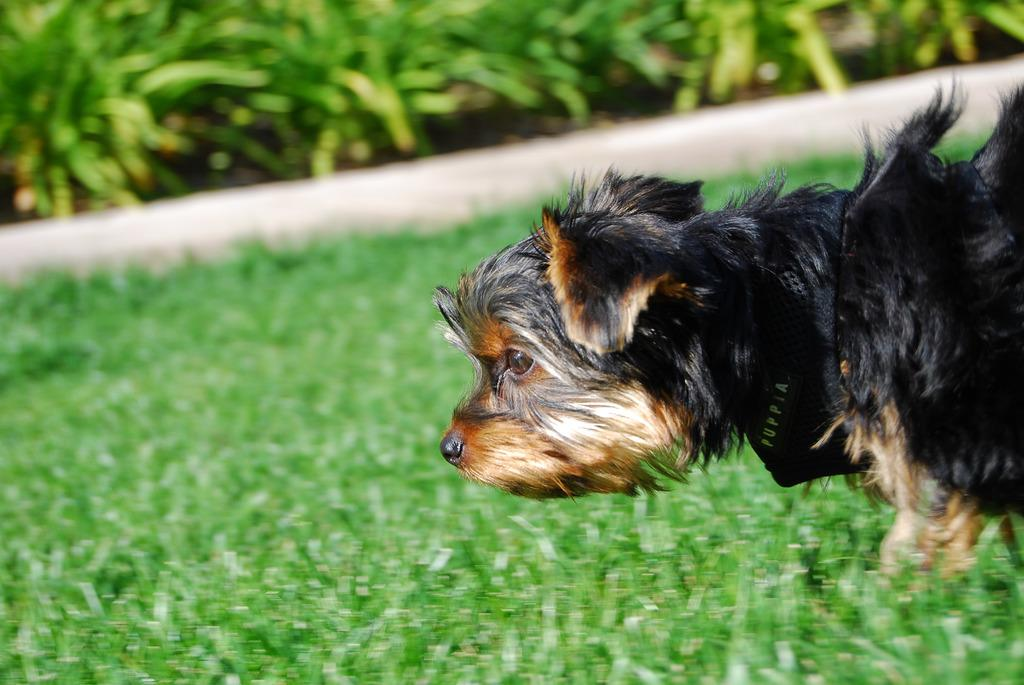What type of animal is in the image? There is a dog in the image. Where is the dog located? The dog is on the surface of the grass. What can be seen in the background of the image? There are plants in the background of the image. What type of brain can be seen in the image? There is no brain present in the image; it features a dog on the grass with plants in the background. 